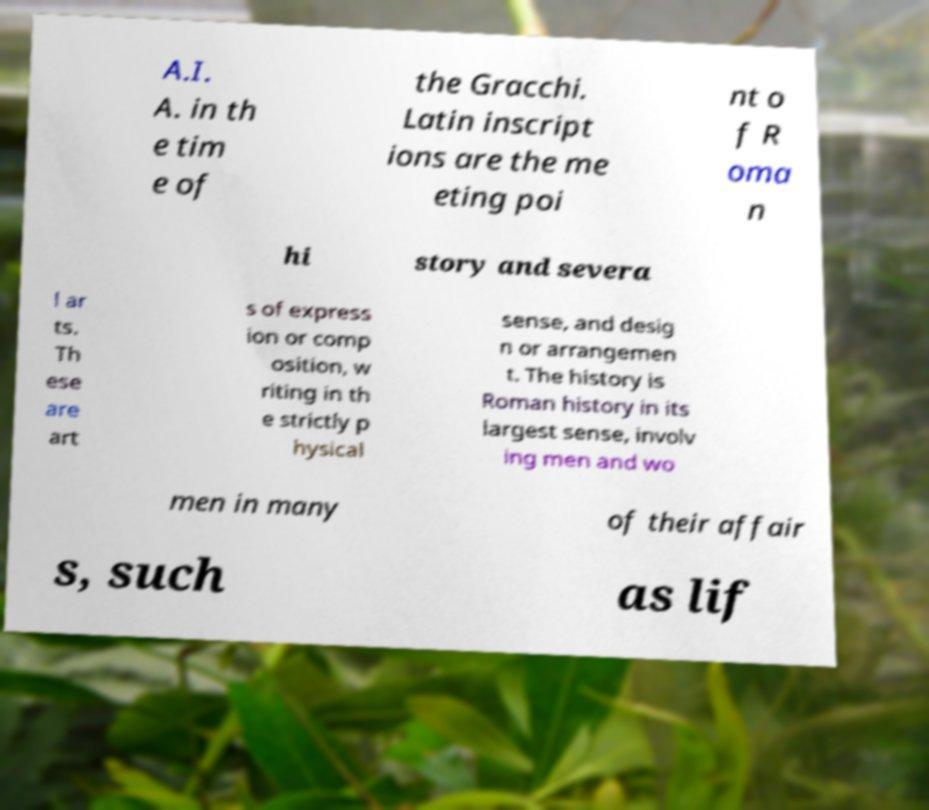Can you read and provide the text displayed in the image?This photo seems to have some interesting text. Can you extract and type it out for me? A.I. A. in th e tim e of the Gracchi. Latin inscript ions are the me eting poi nt o f R oma n hi story and severa l ar ts. Th ese are art s of express ion or comp osition, w riting in th e strictly p hysical sense, and desig n or arrangemen t. The history is Roman history in its largest sense, involv ing men and wo men in many of their affair s, such as lif 